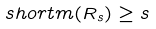Convert formula to latex. <formula><loc_0><loc_0><loc_500><loc_500>\ s h o r t m ( R _ { s } ) \geq s</formula> 